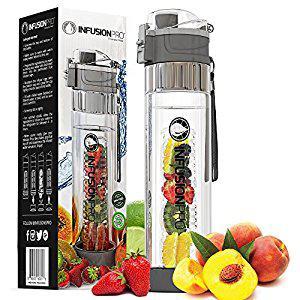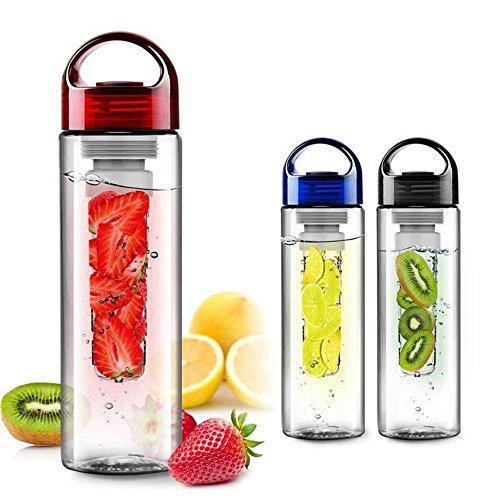The first image is the image on the left, the second image is the image on the right. For the images displayed, is the sentence "Three clear containers stand in a line in one of the images." factually correct? Answer yes or no. Yes. The first image is the image on the left, the second image is the image on the right. Evaluate the accuracy of this statement regarding the images: "An image shows three water bottles posed next to fruits.". Is it true? Answer yes or no. Yes. 